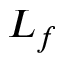Convert formula to latex. <formula><loc_0><loc_0><loc_500><loc_500>L _ { f }</formula> 